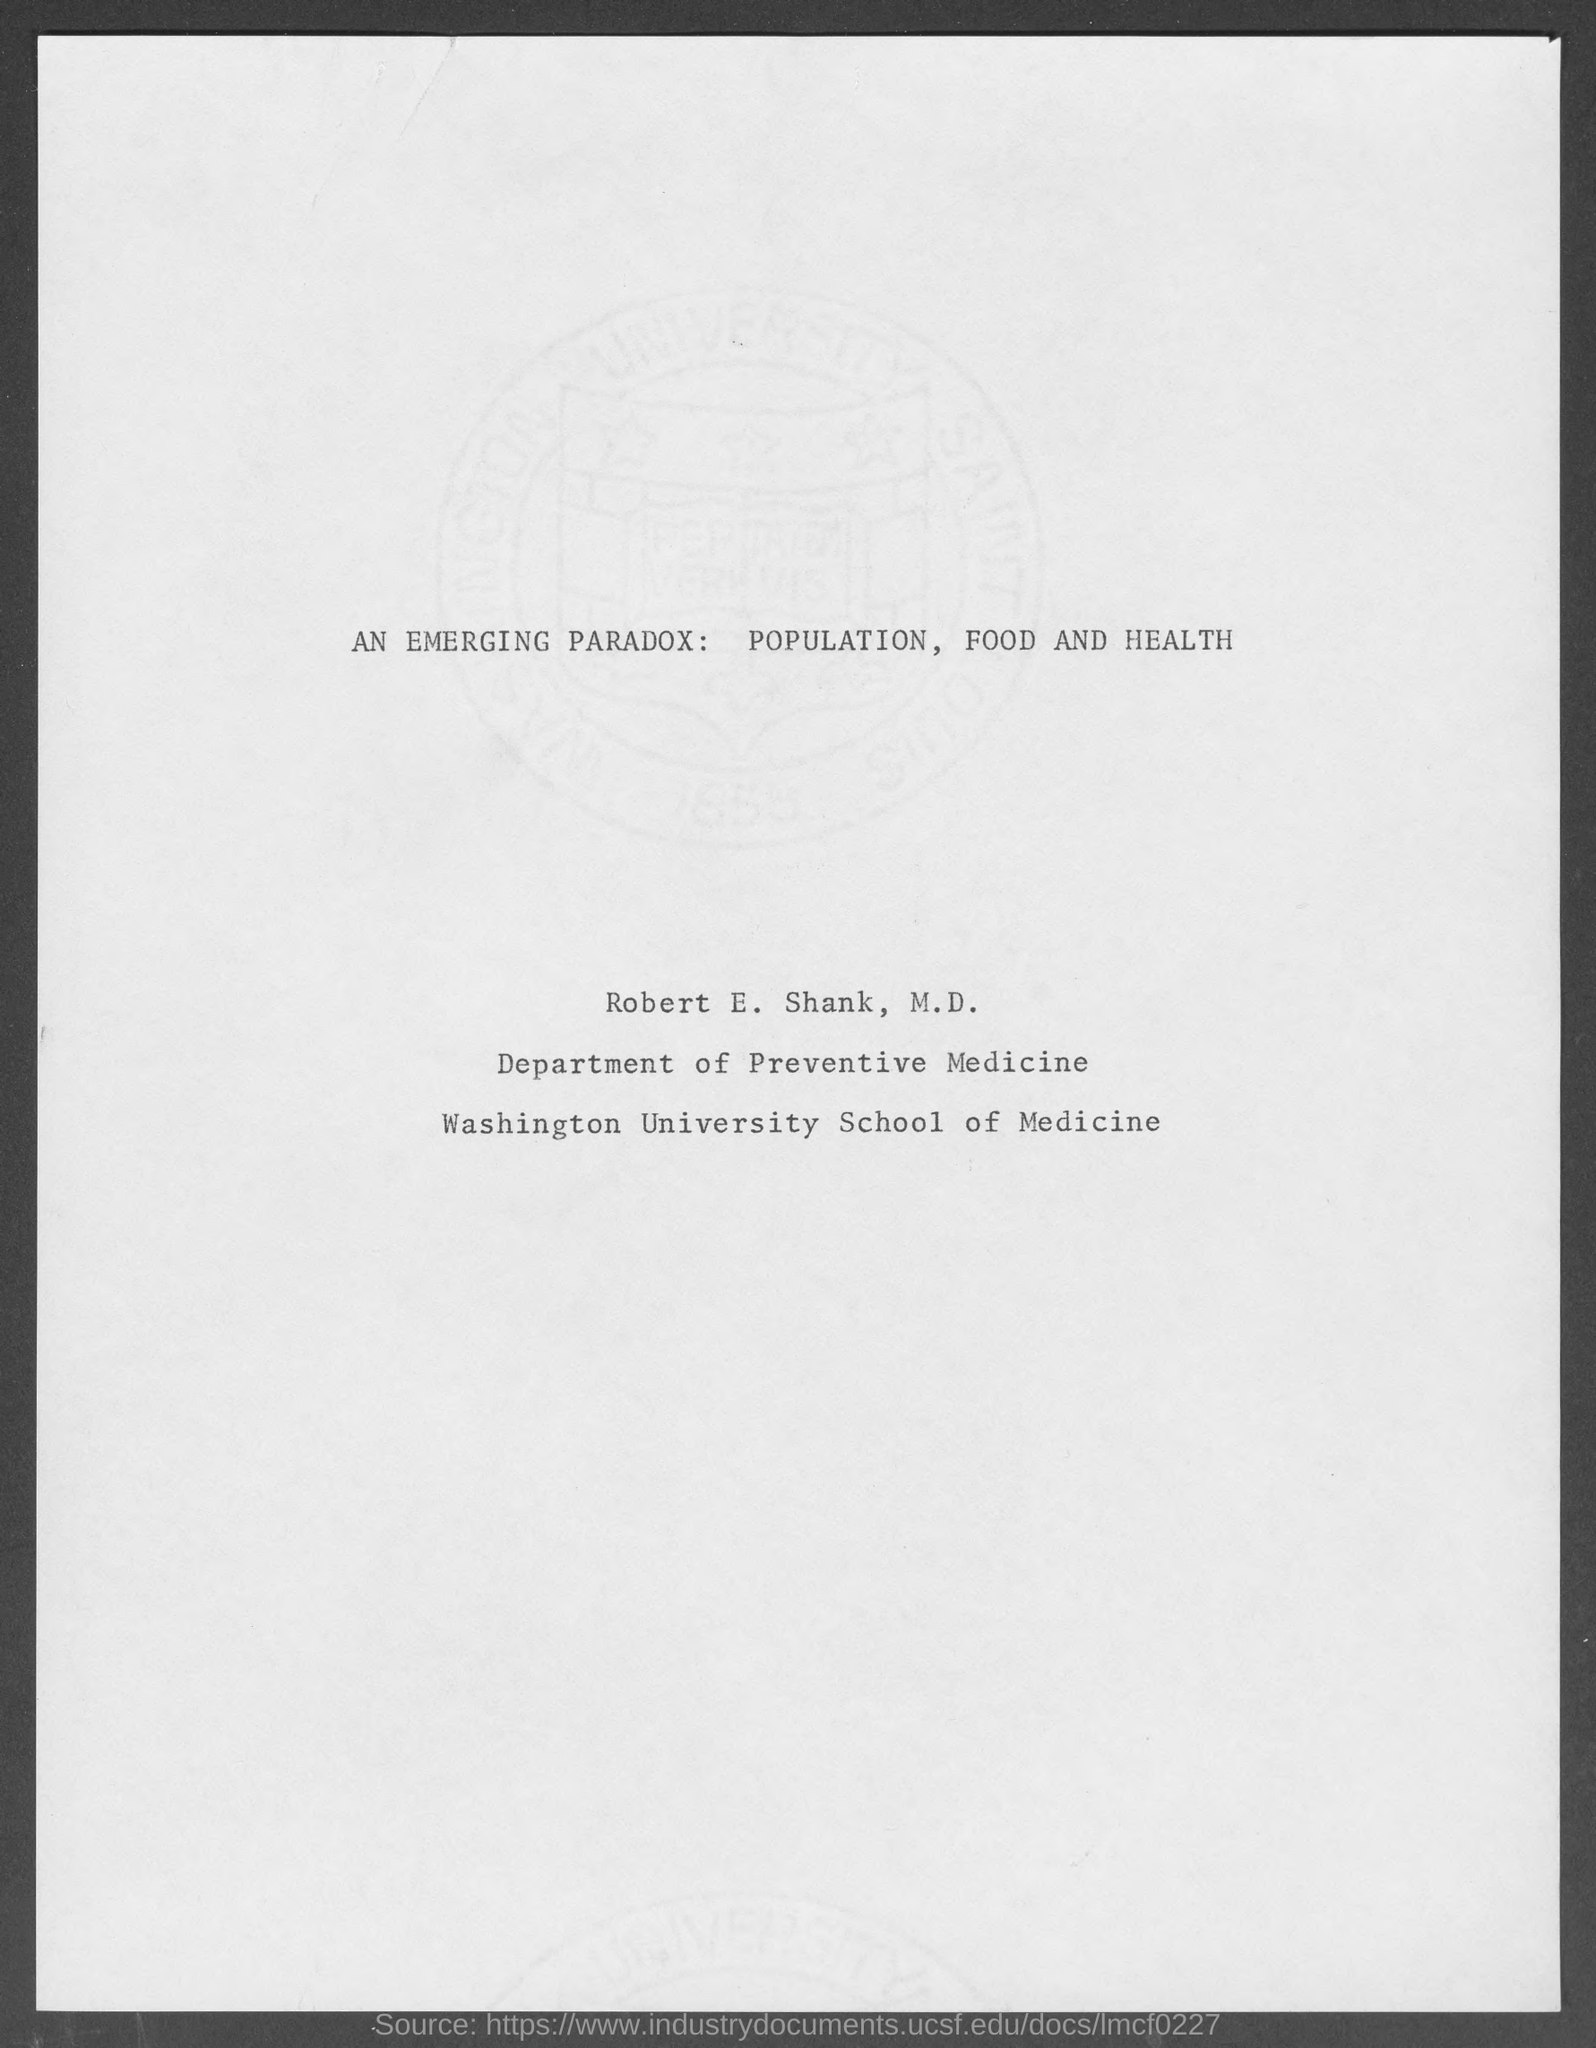Specify some key components in this picture. Robert E. Shank works in the Department of Preventive Medicine. 